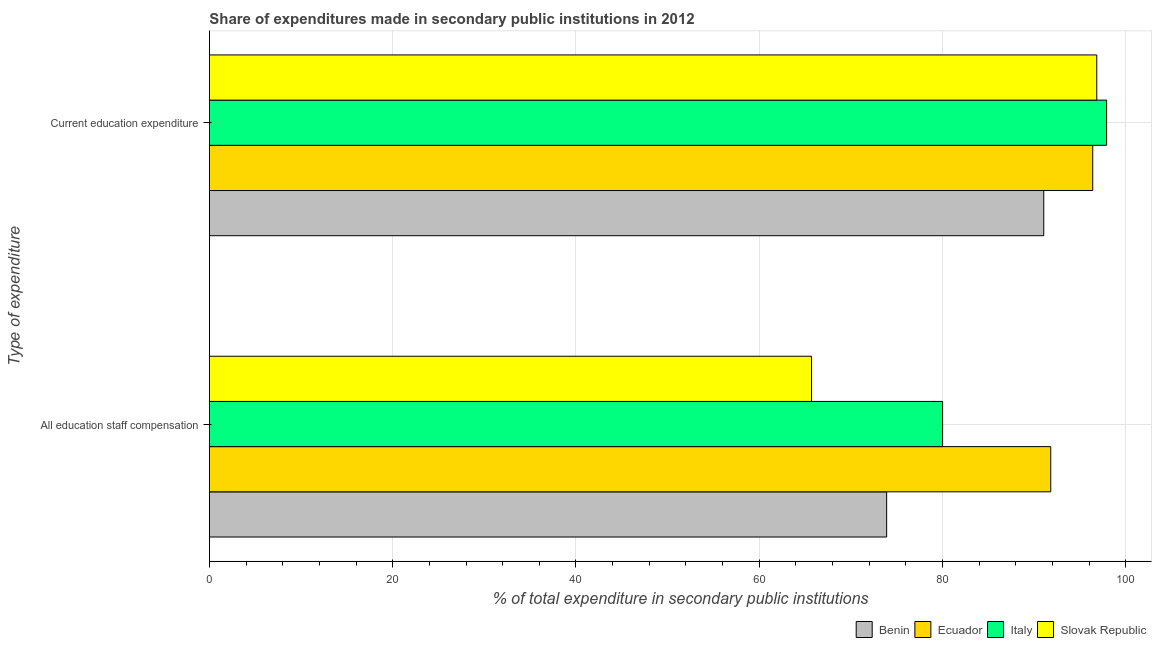Are the number of bars per tick equal to the number of legend labels?
Offer a terse response. Yes. Are the number of bars on each tick of the Y-axis equal?
Ensure brevity in your answer.  Yes. How many bars are there on the 1st tick from the top?
Your response must be concise. 4. How many bars are there on the 1st tick from the bottom?
Your answer should be very brief. 4. What is the label of the 2nd group of bars from the top?
Your answer should be very brief. All education staff compensation. What is the expenditure in staff compensation in Benin?
Provide a short and direct response. 73.91. Across all countries, what is the maximum expenditure in education?
Keep it short and to the point. 97.91. Across all countries, what is the minimum expenditure in staff compensation?
Offer a terse response. 65.7. In which country was the expenditure in education maximum?
Keep it short and to the point. Italy. In which country was the expenditure in staff compensation minimum?
Provide a short and direct response. Slovak Republic. What is the total expenditure in education in the graph?
Your answer should be very brief. 382.2. What is the difference between the expenditure in education in Ecuador and that in Italy?
Provide a succinct answer. -1.52. What is the difference between the expenditure in education in Italy and the expenditure in staff compensation in Benin?
Provide a short and direct response. 24.01. What is the average expenditure in staff compensation per country?
Offer a terse response. 77.86. What is the difference between the expenditure in staff compensation and expenditure in education in Italy?
Provide a succinct answer. -17.9. In how many countries, is the expenditure in staff compensation greater than 48 %?
Offer a terse response. 4. What is the ratio of the expenditure in staff compensation in Italy to that in Ecuador?
Ensure brevity in your answer.  0.87. What does the 1st bar from the top in All education staff compensation represents?
Give a very brief answer. Slovak Republic. What does the 4th bar from the bottom in All education staff compensation represents?
Provide a succinct answer. Slovak Republic. Are all the bars in the graph horizontal?
Provide a succinct answer. Yes. How many countries are there in the graph?
Offer a terse response. 4. Are the values on the major ticks of X-axis written in scientific E-notation?
Your answer should be compact. No. Does the graph contain grids?
Keep it short and to the point. Yes. How are the legend labels stacked?
Give a very brief answer. Horizontal. What is the title of the graph?
Your response must be concise. Share of expenditures made in secondary public institutions in 2012. Does "Equatorial Guinea" appear as one of the legend labels in the graph?
Ensure brevity in your answer.  No. What is the label or title of the X-axis?
Offer a terse response. % of total expenditure in secondary public institutions. What is the label or title of the Y-axis?
Your answer should be compact. Type of expenditure. What is the % of total expenditure in secondary public institutions of Benin in All education staff compensation?
Provide a succinct answer. 73.91. What is the % of total expenditure in secondary public institutions in Ecuador in All education staff compensation?
Make the answer very short. 91.81. What is the % of total expenditure in secondary public institutions of Italy in All education staff compensation?
Your response must be concise. 80.01. What is the % of total expenditure in secondary public institutions in Slovak Republic in All education staff compensation?
Provide a succinct answer. 65.7. What is the % of total expenditure in secondary public institutions in Benin in Current education expenditure?
Provide a short and direct response. 91.05. What is the % of total expenditure in secondary public institutions in Ecuador in Current education expenditure?
Provide a short and direct response. 96.4. What is the % of total expenditure in secondary public institutions of Italy in Current education expenditure?
Your response must be concise. 97.91. What is the % of total expenditure in secondary public institutions in Slovak Republic in Current education expenditure?
Provide a short and direct response. 96.84. Across all Type of expenditure, what is the maximum % of total expenditure in secondary public institutions in Benin?
Ensure brevity in your answer.  91.05. Across all Type of expenditure, what is the maximum % of total expenditure in secondary public institutions of Ecuador?
Give a very brief answer. 96.4. Across all Type of expenditure, what is the maximum % of total expenditure in secondary public institutions of Italy?
Offer a very short reply. 97.91. Across all Type of expenditure, what is the maximum % of total expenditure in secondary public institutions in Slovak Republic?
Your response must be concise. 96.84. Across all Type of expenditure, what is the minimum % of total expenditure in secondary public institutions in Benin?
Your answer should be very brief. 73.91. Across all Type of expenditure, what is the minimum % of total expenditure in secondary public institutions of Ecuador?
Ensure brevity in your answer.  91.81. Across all Type of expenditure, what is the minimum % of total expenditure in secondary public institutions of Italy?
Provide a succinct answer. 80.01. Across all Type of expenditure, what is the minimum % of total expenditure in secondary public institutions of Slovak Republic?
Offer a terse response. 65.7. What is the total % of total expenditure in secondary public institutions of Benin in the graph?
Offer a very short reply. 164.96. What is the total % of total expenditure in secondary public institutions of Ecuador in the graph?
Keep it short and to the point. 188.21. What is the total % of total expenditure in secondary public institutions of Italy in the graph?
Your response must be concise. 177.93. What is the total % of total expenditure in secondary public institutions in Slovak Republic in the graph?
Provide a succinct answer. 162.54. What is the difference between the % of total expenditure in secondary public institutions in Benin in All education staff compensation and that in Current education expenditure?
Your answer should be compact. -17.15. What is the difference between the % of total expenditure in secondary public institutions of Ecuador in All education staff compensation and that in Current education expenditure?
Offer a very short reply. -4.58. What is the difference between the % of total expenditure in secondary public institutions in Italy in All education staff compensation and that in Current education expenditure?
Your response must be concise. -17.9. What is the difference between the % of total expenditure in secondary public institutions of Slovak Republic in All education staff compensation and that in Current education expenditure?
Your answer should be compact. -31.13. What is the difference between the % of total expenditure in secondary public institutions of Benin in All education staff compensation and the % of total expenditure in secondary public institutions of Ecuador in Current education expenditure?
Your response must be concise. -22.49. What is the difference between the % of total expenditure in secondary public institutions in Benin in All education staff compensation and the % of total expenditure in secondary public institutions in Italy in Current education expenditure?
Your answer should be compact. -24.01. What is the difference between the % of total expenditure in secondary public institutions in Benin in All education staff compensation and the % of total expenditure in secondary public institutions in Slovak Republic in Current education expenditure?
Your answer should be compact. -22.93. What is the difference between the % of total expenditure in secondary public institutions of Ecuador in All education staff compensation and the % of total expenditure in secondary public institutions of Italy in Current education expenditure?
Keep it short and to the point. -6.1. What is the difference between the % of total expenditure in secondary public institutions in Ecuador in All education staff compensation and the % of total expenditure in secondary public institutions in Slovak Republic in Current education expenditure?
Offer a very short reply. -5.02. What is the difference between the % of total expenditure in secondary public institutions of Italy in All education staff compensation and the % of total expenditure in secondary public institutions of Slovak Republic in Current education expenditure?
Offer a terse response. -16.82. What is the average % of total expenditure in secondary public institutions of Benin per Type of expenditure?
Make the answer very short. 82.48. What is the average % of total expenditure in secondary public institutions of Ecuador per Type of expenditure?
Ensure brevity in your answer.  94.11. What is the average % of total expenditure in secondary public institutions of Italy per Type of expenditure?
Offer a very short reply. 88.96. What is the average % of total expenditure in secondary public institutions in Slovak Republic per Type of expenditure?
Offer a terse response. 81.27. What is the difference between the % of total expenditure in secondary public institutions of Benin and % of total expenditure in secondary public institutions of Ecuador in All education staff compensation?
Your response must be concise. -17.91. What is the difference between the % of total expenditure in secondary public institutions of Benin and % of total expenditure in secondary public institutions of Italy in All education staff compensation?
Provide a short and direct response. -6.11. What is the difference between the % of total expenditure in secondary public institutions of Benin and % of total expenditure in secondary public institutions of Slovak Republic in All education staff compensation?
Provide a short and direct response. 8.2. What is the difference between the % of total expenditure in secondary public institutions of Ecuador and % of total expenditure in secondary public institutions of Italy in All education staff compensation?
Give a very brief answer. 11.8. What is the difference between the % of total expenditure in secondary public institutions of Ecuador and % of total expenditure in secondary public institutions of Slovak Republic in All education staff compensation?
Your answer should be very brief. 26.11. What is the difference between the % of total expenditure in secondary public institutions in Italy and % of total expenditure in secondary public institutions in Slovak Republic in All education staff compensation?
Give a very brief answer. 14.31. What is the difference between the % of total expenditure in secondary public institutions of Benin and % of total expenditure in secondary public institutions of Ecuador in Current education expenditure?
Offer a very short reply. -5.34. What is the difference between the % of total expenditure in secondary public institutions of Benin and % of total expenditure in secondary public institutions of Italy in Current education expenditure?
Provide a short and direct response. -6.86. What is the difference between the % of total expenditure in secondary public institutions in Benin and % of total expenditure in secondary public institutions in Slovak Republic in Current education expenditure?
Provide a short and direct response. -5.79. What is the difference between the % of total expenditure in secondary public institutions of Ecuador and % of total expenditure in secondary public institutions of Italy in Current education expenditure?
Give a very brief answer. -1.52. What is the difference between the % of total expenditure in secondary public institutions of Ecuador and % of total expenditure in secondary public institutions of Slovak Republic in Current education expenditure?
Your response must be concise. -0.44. What is the difference between the % of total expenditure in secondary public institutions of Italy and % of total expenditure in secondary public institutions of Slovak Republic in Current education expenditure?
Give a very brief answer. 1.08. What is the ratio of the % of total expenditure in secondary public institutions in Benin in All education staff compensation to that in Current education expenditure?
Offer a terse response. 0.81. What is the ratio of the % of total expenditure in secondary public institutions of Ecuador in All education staff compensation to that in Current education expenditure?
Your answer should be very brief. 0.95. What is the ratio of the % of total expenditure in secondary public institutions in Italy in All education staff compensation to that in Current education expenditure?
Offer a terse response. 0.82. What is the ratio of the % of total expenditure in secondary public institutions of Slovak Republic in All education staff compensation to that in Current education expenditure?
Make the answer very short. 0.68. What is the difference between the highest and the second highest % of total expenditure in secondary public institutions of Benin?
Your answer should be compact. 17.15. What is the difference between the highest and the second highest % of total expenditure in secondary public institutions of Ecuador?
Your response must be concise. 4.58. What is the difference between the highest and the second highest % of total expenditure in secondary public institutions of Italy?
Your answer should be compact. 17.9. What is the difference between the highest and the second highest % of total expenditure in secondary public institutions in Slovak Republic?
Your response must be concise. 31.13. What is the difference between the highest and the lowest % of total expenditure in secondary public institutions of Benin?
Give a very brief answer. 17.15. What is the difference between the highest and the lowest % of total expenditure in secondary public institutions in Ecuador?
Make the answer very short. 4.58. What is the difference between the highest and the lowest % of total expenditure in secondary public institutions in Italy?
Provide a succinct answer. 17.9. What is the difference between the highest and the lowest % of total expenditure in secondary public institutions of Slovak Republic?
Ensure brevity in your answer.  31.13. 